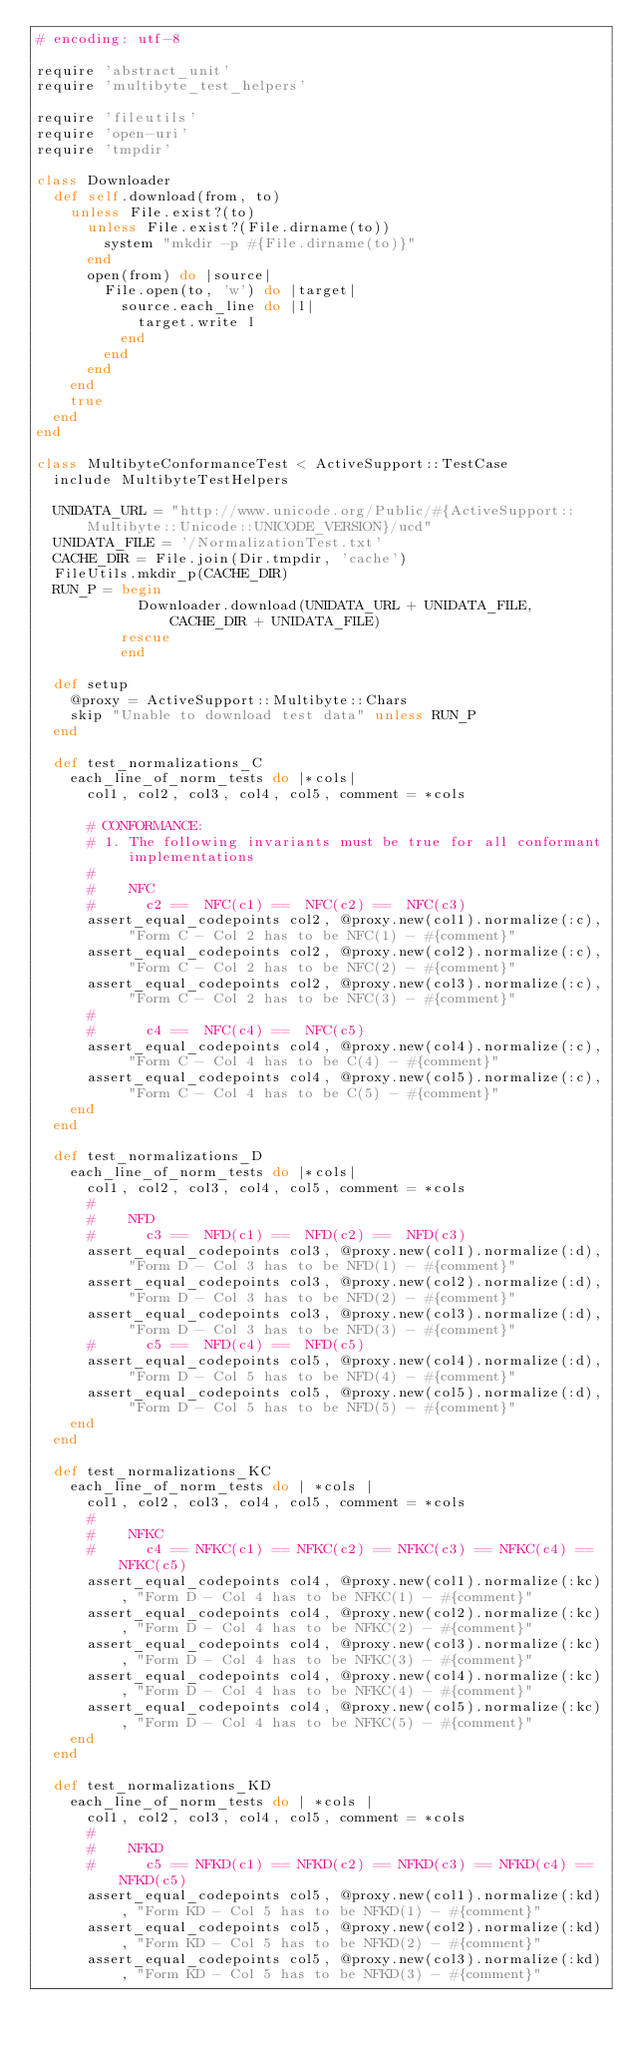Convert code to text. <code><loc_0><loc_0><loc_500><loc_500><_Ruby_># encoding: utf-8

require 'abstract_unit'
require 'multibyte_test_helpers'

require 'fileutils'
require 'open-uri'
require 'tmpdir'

class Downloader
  def self.download(from, to)
    unless File.exist?(to)
      unless File.exist?(File.dirname(to))
        system "mkdir -p #{File.dirname(to)}"
      end
      open(from) do |source|
        File.open(to, 'w') do |target|
          source.each_line do |l|
            target.write l
          end
        end
      end
    end
    true
  end
end

class MultibyteConformanceTest < ActiveSupport::TestCase
  include MultibyteTestHelpers

  UNIDATA_URL = "http://www.unicode.org/Public/#{ActiveSupport::Multibyte::Unicode::UNICODE_VERSION}/ucd"
  UNIDATA_FILE = '/NormalizationTest.txt'
  CACHE_DIR = File.join(Dir.tmpdir, 'cache')
  FileUtils.mkdir_p(CACHE_DIR)
  RUN_P = begin
            Downloader.download(UNIDATA_URL + UNIDATA_FILE, CACHE_DIR + UNIDATA_FILE)
          rescue
          end

  def setup
    @proxy = ActiveSupport::Multibyte::Chars
    skip "Unable to download test data" unless RUN_P
  end

  def test_normalizations_C
    each_line_of_norm_tests do |*cols|
      col1, col2, col3, col4, col5, comment = *cols

      # CONFORMANCE:
      # 1. The following invariants must be true for all conformant implementations
      #
      #    NFC
      #      c2 ==  NFC(c1) ==  NFC(c2) ==  NFC(c3)
      assert_equal_codepoints col2, @proxy.new(col1).normalize(:c), "Form C - Col 2 has to be NFC(1) - #{comment}"
      assert_equal_codepoints col2, @proxy.new(col2).normalize(:c), "Form C - Col 2 has to be NFC(2) - #{comment}"
      assert_equal_codepoints col2, @proxy.new(col3).normalize(:c), "Form C - Col 2 has to be NFC(3) - #{comment}"
      #
      #      c4 ==  NFC(c4) ==  NFC(c5)
      assert_equal_codepoints col4, @proxy.new(col4).normalize(:c), "Form C - Col 4 has to be C(4) - #{comment}"
      assert_equal_codepoints col4, @proxy.new(col5).normalize(:c), "Form C - Col 4 has to be C(5) - #{comment}"
    end
  end

  def test_normalizations_D
    each_line_of_norm_tests do |*cols|
      col1, col2, col3, col4, col5, comment = *cols
      #
      #    NFD
      #      c3 ==  NFD(c1) ==  NFD(c2) ==  NFD(c3)
      assert_equal_codepoints col3, @proxy.new(col1).normalize(:d), "Form D - Col 3 has to be NFD(1) - #{comment}"
      assert_equal_codepoints col3, @proxy.new(col2).normalize(:d), "Form D - Col 3 has to be NFD(2) - #{comment}"
      assert_equal_codepoints col3, @proxy.new(col3).normalize(:d), "Form D - Col 3 has to be NFD(3) - #{comment}"
      #      c5 ==  NFD(c4) ==  NFD(c5)
      assert_equal_codepoints col5, @proxy.new(col4).normalize(:d), "Form D - Col 5 has to be NFD(4) - #{comment}"
      assert_equal_codepoints col5, @proxy.new(col5).normalize(:d), "Form D - Col 5 has to be NFD(5) - #{comment}"
    end
  end

  def test_normalizations_KC
    each_line_of_norm_tests do | *cols |
      col1, col2, col3, col4, col5, comment = *cols
      #
      #    NFKC
      #      c4 == NFKC(c1) == NFKC(c2) == NFKC(c3) == NFKC(c4) == NFKC(c5)
      assert_equal_codepoints col4, @proxy.new(col1).normalize(:kc), "Form D - Col 4 has to be NFKC(1) - #{comment}"
      assert_equal_codepoints col4, @proxy.new(col2).normalize(:kc), "Form D - Col 4 has to be NFKC(2) - #{comment}"
      assert_equal_codepoints col4, @proxy.new(col3).normalize(:kc), "Form D - Col 4 has to be NFKC(3) - #{comment}"
      assert_equal_codepoints col4, @proxy.new(col4).normalize(:kc), "Form D - Col 4 has to be NFKC(4) - #{comment}"
      assert_equal_codepoints col4, @proxy.new(col5).normalize(:kc), "Form D - Col 4 has to be NFKC(5) - #{comment}"
    end
  end

  def test_normalizations_KD
    each_line_of_norm_tests do | *cols |
      col1, col2, col3, col4, col5, comment = *cols
      #
      #    NFKD
      #      c5 == NFKD(c1) == NFKD(c2) == NFKD(c3) == NFKD(c4) == NFKD(c5)
      assert_equal_codepoints col5, @proxy.new(col1).normalize(:kd), "Form KD - Col 5 has to be NFKD(1) - #{comment}"
      assert_equal_codepoints col5, @proxy.new(col2).normalize(:kd), "Form KD - Col 5 has to be NFKD(2) - #{comment}"
      assert_equal_codepoints col5, @proxy.new(col3).normalize(:kd), "Form KD - Col 5 has to be NFKD(3) - #{comment}"</code> 